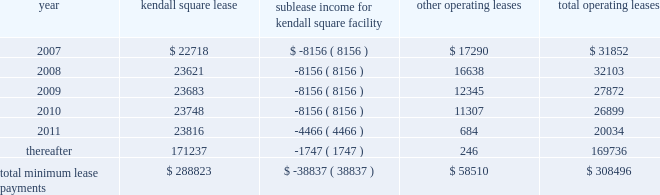Vertex pharmaceuticals incorporated notes to consolidated financial statements ( continued ) k .
Commitments ( continued ) at december 31 , 2006 , future minimum commitments under facility operating leases with non-cancelable terms of more than one year ( including commitments under the kendall square lease ) are as follows ( in thousands ) : rental expense for 2006 was $ 26.7 million , which included $ 9.5 million related to the kendall square facility .
Rental expense for 2005 was $ 20.4 million , which included $ 4.7 million related to the space in the kendall square facility that the company occupied in 2006 in the kendall square facility .
For 2004 , rental expense primarily related to facilities , excluding the kendall square facility , was $ 16.3 million .
The company has future contractual commitments in connection with its research and development programs .
For 2007 and 2008 the amount committed under these contracts is $ 1.1 million and $ 0.6 million , respectively .
Convertible subordinated notes on february 13 , 2004 , the company issued approximately $ 153.1 million in aggregate principal amount of 5.75% ( 5.75 % ) convertible senior subordinated notes due in february 2011 ( the 201cfebruary 2011 notes 201d ) in exchange for an equal principal amount of its outstanding 5% ( 5 % ) convertible subordinated notes due in september 2007 ( the 201c2007 notes 201d ) .
On september 17 , 2004 , the company issued approximately $ 79.3 million in aggregate principal amount of 5.75% ( 5.75 % ) convertible senior subordinated notes due in february 2011 ( the 201cseptember 2011 notes 201d ) in exchange for an equal principal amount of its 2007 notes .
The terms of the september 2011 notes are identical to those of the february 2011 notes ( the february 2011 notes and the september 2011 notes are referred to together as the 201c2011 notes 201d ) .
The 2011 notes are convertible , at the option of the holder , into common stock at a price equal to $ 14.94 per share , subject to adjustment under certain circumstances .
The 2011 notes bear interest at the rate of 5.75% ( 5.75 % ) per annum , and the company is required to make semi-annual interest payments on the outstanding principal balance of the 2011 notes on february 15 and august 15 of each year .
On or after february 15 , 2007 , the company may redeem the 2011 notes at a redemption price equal to the principal amount plus accrued and unpaid interest , if any .
The deferred issuance costs associated with the issuance of the 2011 notes , which are classified as long-term other assets , were approximately $ 3.0 million for the february 2011 notes and $ 1.9 million for the september 2011 notes .
The 2007 notes are convertible , at the option of the holder , into common stock at a price equal to $ 92.26 per share , subject to adjustment under certain circumstances .
The 2007 notes bear interest at the rate of 5% ( 5 % ) per annum , and the company is required to make semi-annual interest payments on the outstanding principal balance of the 2007 notes on march 19 and september 19 of each year .
The 2007 notes are redeemable by the company at any time at specific redemption prices if the closing price of the kendall square sublease income for kendall square facility other operating leases total operating leases $ 22718 $ ( 8156 ) $ 17290 $ 31852 23621 ( 8156 ) 16638 32103 23683 ( 8156 ) 12345 27872 23748 ( 8156 ) 11307 26899 23816 ( 4466 ) 684 20034 thereafter 171237 ( 1747 ) 246 169736 total minimum lease payments $ 288823 $ ( 38837 ) $ 58510 $ 308496 .
Vertex pharmaceuticals incorporated notes to consolidated financial statements ( continued ) k .
Commitments ( continued ) at december 31 , 2006 , future minimum commitments under facility operating leases with non-cancelable terms of more than one year ( including commitments under the kendall square lease ) are as follows ( in thousands ) : rental expense for 2006 was $ 26.7 million , which included $ 9.5 million related to the kendall square facility .
Rental expense for 2005 was $ 20.4 million , which included $ 4.7 million related to the space in the kendall square facility that the company occupied in 2006 in the kendall square facility .
For 2004 , rental expense primarily related to facilities , excluding the kendall square facility , was $ 16.3 million .
The company has future contractual commitments in connection with its research and development programs .
For 2007 and 2008 the amount committed under these contracts is $ 1.1 million and $ 0.6 million , respectively .
Convertible subordinated notes on february 13 , 2004 , the company issued approximately $ 153.1 million in aggregate principal amount of 5.75% ( 5.75 % ) convertible senior subordinated notes due in february 2011 ( the 201cfebruary 2011 notes 201d ) in exchange for an equal principal amount of its outstanding 5% ( 5 % ) convertible subordinated notes due in september 2007 ( the 201c2007 notes 201d ) .
On september 17 , 2004 , the company issued approximately $ 79.3 million in aggregate principal amount of 5.75% ( 5.75 % ) convertible senior subordinated notes due in february 2011 ( the 201cseptember 2011 notes 201d ) in exchange for an equal principal amount of its 2007 notes .
The terms of the september 2011 notes are identical to those of the february 2011 notes ( the february 2011 notes and the september 2011 notes are referred to together as the 201c2011 notes 201d ) .
The 2011 notes are convertible , at the option of the holder , into common stock at a price equal to $ 14.94 per share , subject to adjustment under certain circumstances .
The 2011 notes bear interest at the rate of 5.75% ( 5.75 % ) per annum , and the company is required to make semi-annual interest payments on the outstanding principal balance of the 2011 notes on february 15 and august 15 of each year .
On or after february 15 , 2007 , the company may redeem the 2011 notes at a redemption price equal to the principal amount plus accrued and unpaid interest , if any .
The deferred issuance costs associated with the issuance of the 2011 notes , which are classified as long-term other assets , were approximately $ 3.0 million for the february 2011 notes and $ 1.9 million for the september 2011 notes .
The 2007 notes are convertible , at the option of the holder , into common stock at a price equal to $ 92.26 per share , subject to adjustment under certain circumstances .
The 2007 notes bear interest at the rate of 5% ( 5 % ) per annum , and the company is required to make semi-annual interest payments on the outstanding principal balance of the 2007 notes on march 19 and september 19 of each year .
The 2007 notes are redeemable by the company at any time at specific redemption prices if the closing price of the kendall square sublease income for kendall square facility other operating leases total operating leases $ 22718 $ ( 8156 ) $ 17290 $ 31852 23621 ( 8156 ) 16638 32103 23683 ( 8156 ) 12345 27872 23748 ( 8156 ) 11307 26899 23816 ( 4466 ) 684 20034 thereafter 171237 ( 1747 ) 246 169736 total minimum lease payments $ 288823 $ ( 38837 ) $ 58510 $ 308496 .
What percent of the total operating leases in 2007 are not related to the kendall square lease? 
Computations: (17290 / 31852)
Answer: 0.54282. 